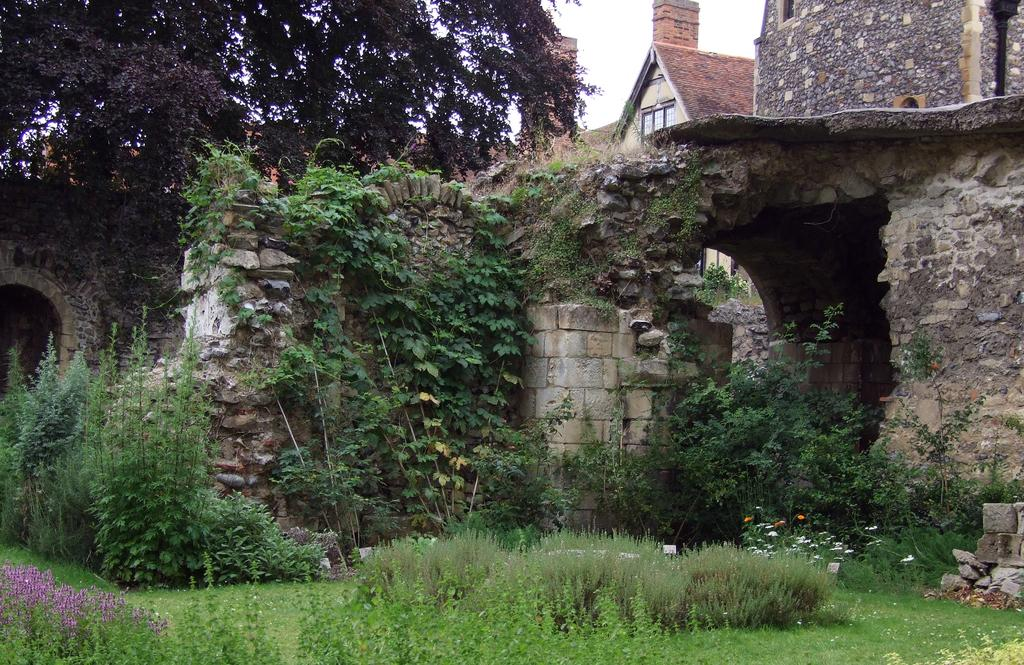What type of vegetation is at the bottom of the image? There are plants at the bottom of the image. What other type of vegetation can be seen in the image? There are trees in the image. What structure is visible in the image? There is a wall in the image. What type of building is present in the image? There is a house in the image. What is visible in the background of the image? The sky is visible in the background of the image. What color is the science point in the image? There is no mention of a science point or any color in the image. The image features plants, trees, a wall, a house, and the sky. 